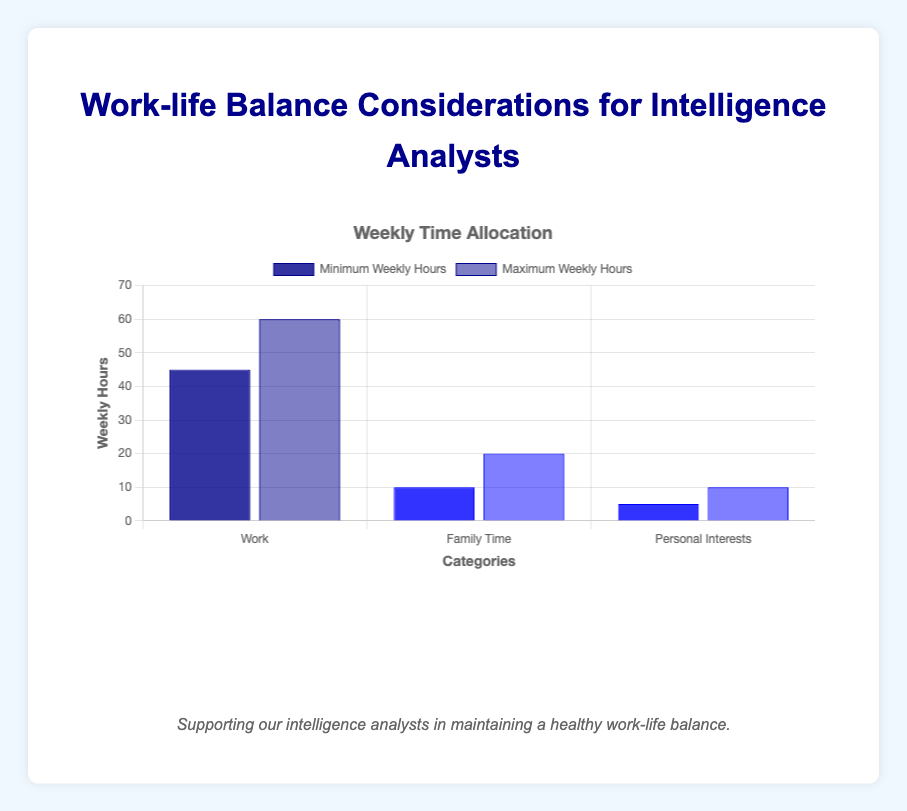What is the minimum weekly hours spent on work? The bar chart shows "Minimum Weekly Hours" for the "Work" category. The value indicated is 45 hours.
Answer: 45 How many more hours are spent on work than on personal interests (maximum hours)? Compare the "Maximum Weekly Hours" for "Work" (60 hours) and "Personal Interests" (10 hours). The difference is 60 - 10 = 50 hours.
Answer: 50 Which category has the highest minimum weekly hours? The categories are "Work," "Family Time," and "Personal Interests." The minimum weekly hours for each are 45, 10, and 5 respectively. "Work" has the highest minimum weekly hours.
Answer: Work What is the average minimum weekly hours spent on all categories? The minimum weekly hours for "Work," "Family Time," and "Personal Interests" are 45, 10, and 5 respectively. The average is (45 + 10 + 5) / 3 = 20 hours.
Answer: 20 Which category uses the blue bars? By visual inspection of the color scheme and categories, "Family Time" and "Personal Interests" use blue bars, while "Work" uses dark blue bars.
Answer: Family Time, Personal Interests What is the minimum gap between minimum and maximum weekly hours within any category? For "Work," the gap is 60 - 45 = 15 hours. For "Family Time," the gap is 20 - 10 = 10 hours. For "Personal Interests," the gap is 10 - 5 = 5 hours. The smallest gap is 5 hours for "Personal Interests."
Answer: 5 What is the total maximum weekly hours spent on family time and personal interests combined? The maximum weekly hours for "Family Time" is 20 and for "Personal Interests" is 10. The total is 20 + 10 = 30 hours.
Answer: 30 Which category shows the smallest range of weekly hours? The range of weekly hours is calculated as the difference between maximum and minimum hours. For "Work," the range is 60 - 45 = 15 hours. For "Family Time," the range is 20 - 10 = 10 hours. For "Personal Interests," the range is 10 - 5 = 5 hours. The smallest range is for "Personal Interests."
Answer: Personal Interests What is the maximum time allocation for work as compared to the other two categories? The maximum weekly hours for "Work" is 60. For "Family Time," it is 20, and for "Personal Interests," it is 10. Therefore, 60 is significantly higher than 20 and 10.
Answer: 60 